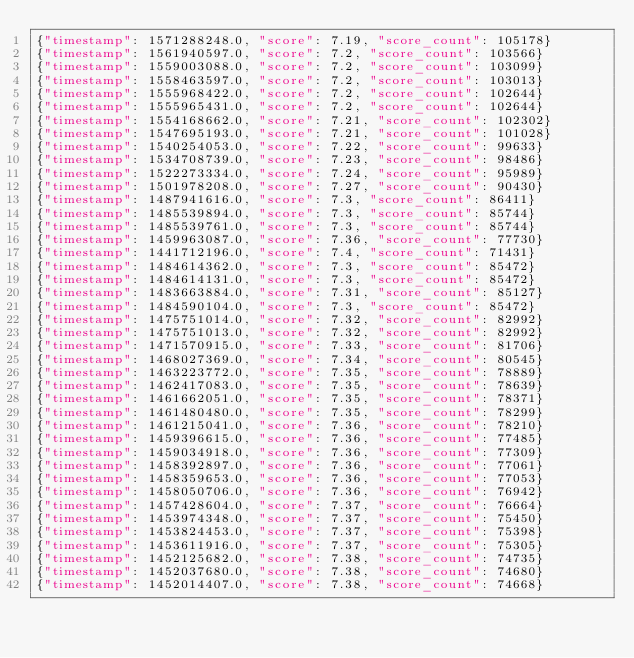Convert code to text. <code><loc_0><loc_0><loc_500><loc_500><_Julia_>{"timestamp": 1571288248.0, "score": 7.19, "score_count": 105178}
{"timestamp": 1561940597.0, "score": 7.2, "score_count": 103566}
{"timestamp": 1559003088.0, "score": 7.2, "score_count": 103099}
{"timestamp": 1558463597.0, "score": 7.2, "score_count": 103013}
{"timestamp": 1555968422.0, "score": 7.2, "score_count": 102644}
{"timestamp": 1555965431.0, "score": 7.2, "score_count": 102644}
{"timestamp": 1554168662.0, "score": 7.21, "score_count": 102302}
{"timestamp": 1547695193.0, "score": 7.21, "score_count": 101028}
{"timestamp": 1540254053.0, "score": 7.22, "score_count": 99633}
{"timestamp": 1534708739.0, "score": 7.23, "score_count": 98486}
{"timestamp": 1522273334.0, "score": 7.24, "score_count": 95989}
{"timestamp": 1501978208.0, "score": 7.27, "score_count": 90430}
{"timestamp": 1487941616.0, "score": 7.3, "score_count": 86411}
{"timestamp": 1485539894.0, "score": 7.3, "score_count": 85744}
{"timestamp": 1485539761.0, "score": 7.3, "score_count": 85744}
{"timestamp": 1459963087.0, "score": 7.36, "score_count": 77730}
{"timestamp": 1441712196.0, "score": 7.4, "score_count": 71431}
{"timestamp": 1484614362.0, "score": 7.3, "score_count": 85472}
{"timestamp": 1484614131.0, "score": 7.3, "score_count": 85472}
{"timestamp": 1483663884.0, "score": 7.31, "score_count": 85127}
{"timestamp": 1484590104.0, "score": 7.3, "score_count": 85472}
{"timestamp": 1475751014.0, "score": 7.32, "score_count": 82992}
{"timestamp": 1475751013.0, "score": 7.32, "score_count": 82992}
{"timestamp": 1471570915.0, "score": 7.33, "score_count": 81706}
{"timestamp": 1468027369.0, "score": 7.34, "score_count": 80545}
{"timestamp": 1463223772.0, "score": 7.35, "score_count": 78889}
{"timestamp": 1462417083.0, "score": 7.35, "score_count": 78639}
{"timestamp": 1461662051.0, "score": 7.35, "score_count": 78371}
{"timestamp": 1461480480.0, "score": 7.35, "score_count": 78299}
{"timestamp": 1461215041.0, "score": 7.36, "score_count": 78210}
{"timestamp": 1459396615.0, "score": 7.36, "score_count": 77485}
{"timestamp": 1459034918.0, "score": 7.36, "score_count": 77309}
{"timestamp": 1458392897.0, "score": 7.36, "score_count": 77061}
{"timestamp": 1458359653.0, "score": 7.36, "score_count": 77053}
{"timestamp": 1458050706.0, "score": 7.36, "score_count": 76942}
{"timestamp": 1457428604.0, "score": 7.37, "score_count": 76664}
{"timestamp": 1453974348.0, "score": 7.37, "score_count": 75450}
{"timestamp": 1453824453.0, "score": 7.37, "score_count": 75398}
{"timestamp": 1453611916.0, "score": 7.37, "score_count": 75305}
{"timestamp": 1452125682.0, "score": 7.38, "score_count": 74735}
{"timestamp": 1452037680.0, "score": 7.38, "score_count": 74680}
{"timestamp": 1452014407.0, "score": 7.38, "score_count": 74668}
</code> 